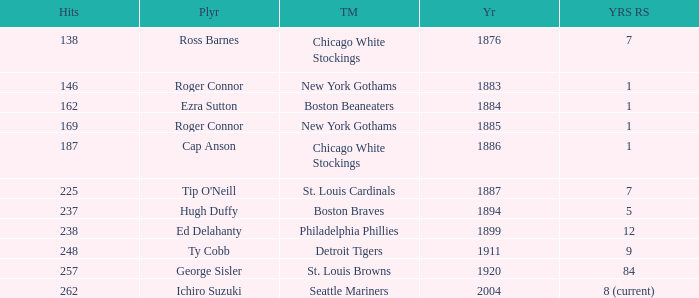Name the player with 238 hits and years after 1885 Ed Delahanty. 